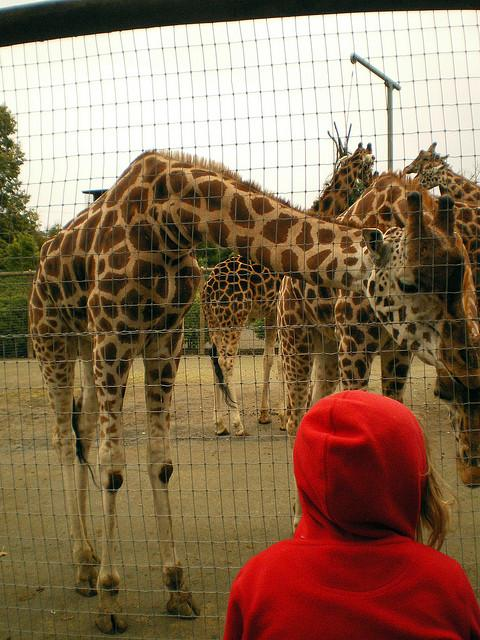How many of the giraffes are attentive to the child? Please explain your reasoning. two. Two giraffes are facing a child at a fence. 